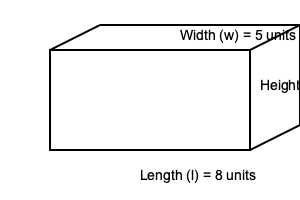Given a rectangular prism with dimensions length (l) = 8 units, width (w) = 5 units, and height (h) = 4 units, calculate its volume. How would you represent this calculation using TensorFlow operations? To solve this problem and represent it using TensorFlow operations, we can follow these steps:

1. Recall the formula for the volume of a rectangular prism:
   $$ V = l \times w \times h $$

2. Substitute the given values:
   $$ V = 8 \times 5 \times 4 $$

3. To represent this calculation using TensorFlow operations, we can use the following code:

   ```python
   import tensorflow as tf

   # Define the dimensions as tf.constant
   length = tf.constant(8.0, dtype=tf.float32)
   width = tf.constant(5.0, dtype=tf.float32)
   height = tf.constant(4.0, dtype=tf.float32)

   # Calculate the volume using tf.multiply
   volume = tf.multiply(tf.multiply(length, width), height)
   ```

4. The `tf.multiply` operation performs element-wise multiplication. We use it twice to multiply all three dimensions.

5. To get the final result, we would need to evaluate the `volume` tensor in a TensorFlow session or use `tf.print(volume)` in eager execution mode.

6. The calculated volume is:
   $$ V = 8 \times 5 \times 4 = 160 \text{ cubic units} $$

This approach demonstrates how basic arithmetic operations can be performed using TensorFlow, which is relevant to the persona of a Senior AI researcher with expertise in TensorFlow.
Answer: 160 cubic units; tf.multiply(tf.multiply(length, width), height) 